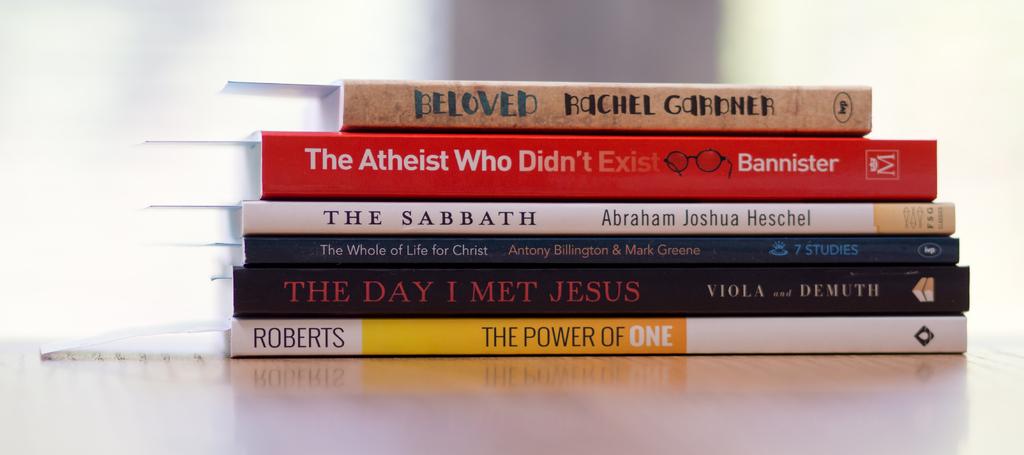Who is the author of "beloved?"?
Make the answer very short. Rachel gardner. 